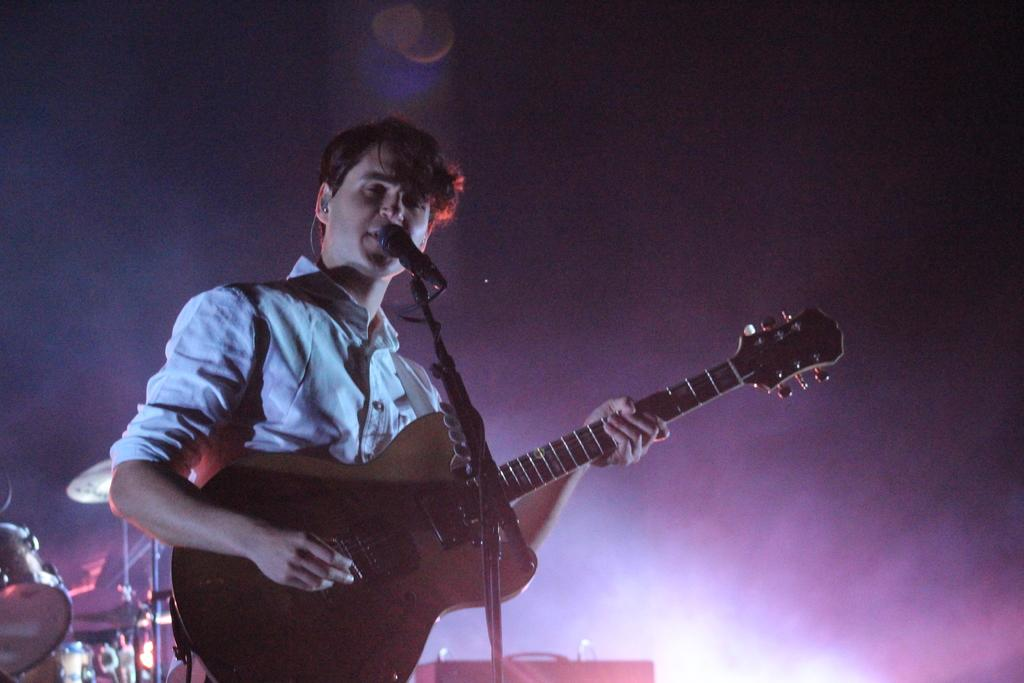What is the person in the image doing? The person is playing a guitar and singing. What instrument can be seen behind the person? There are drums visible behind the person. What device is in front of the person? There is a microphone in front of the person. What type of suit is the spy wearing in the image? There is no spy or suit present in the image; it features a person playing a guitar and singing. 